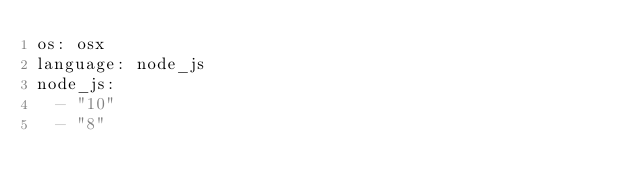<code> <loc_0><loc_0><loc_500><loc_500><_YAML_>os: osx
language: node_js
node_js:
  - "10"
  - "8"
</code> 